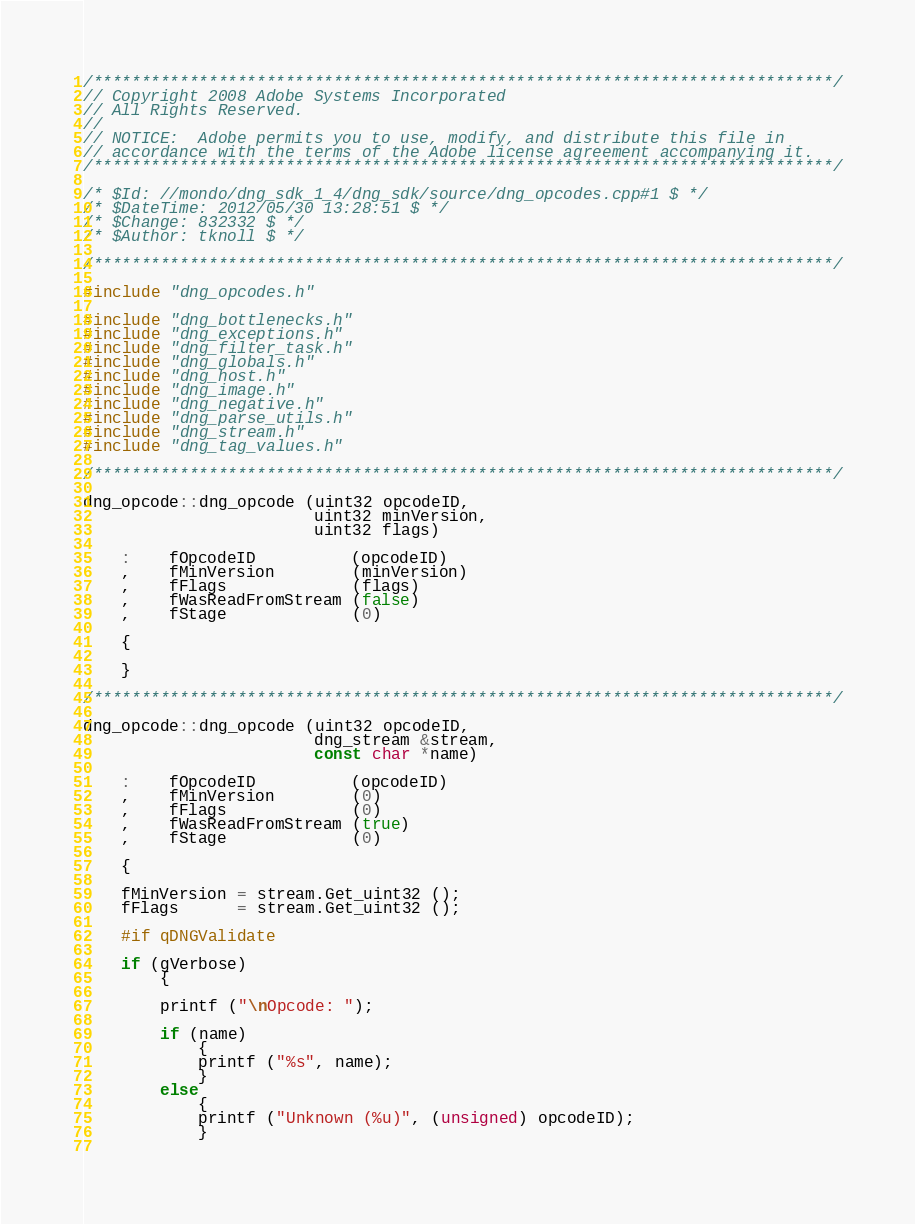<code> <loc_0><loc_0><loc_500><loc_500><_C++_>/*****************************************************************************/
// Copyright 2008 Adobe Systems Incorporated
// All Rights Reserved.
//
// NOTICE:  Adobe permits you to use, modify, and distribute this file in
// accordance with the terms of the Adobe license agreement accompanying it.
/*****************************************************************************/

/* $Id: //mondo/dng_sdk_1_4/dng_sdk/source/dng_opcodes.cpp#1 $ */ 
/* $DateTime: 2012/05/30 13:28:51 $ */
/* $Change: 832332 $ */
/* $Author: tknoll $ */

/*****************************************************************************/

#include "dng_opcodes.h"

#include "dng_bottlenecks.h"
#include "dng_exceptions.h"
#include "dng_filter_task.h"
#include "dng_globals.h"
#include "dng_host.h"
#include "dng_image.h"
#include "dng_negative.h"
#include "dng_parse_utils.h"
#include "dng_stream.h"
#include "dng_tag_values.h"

/*****************************************************************************/

dng_opcode::dng_opcode (uint32 opcodeID,
						uint32 minVersion,
						uint32 flags)
						
	:	fOpcodeID          (opcodeID)
	,	fMinVersion        (minVersion)
	,	fFlags             (flags)
	,	fWasReadFromStream (false)
	,	fStage             (0)
	
	{
	
	}
					
/*****************************************************************************/

dng_opcode::dng_opcode (uint32 opcodeID,
					    dng_stream &stream,
						const char *name)
						
	:	fOpcodeID          (opcodeID)
	,	fMinVersion        (0)
	,	fFlags             (0)
	,	fWasReadFromStream (true)
	,	fStage             (0)
	
	{
	
	fMinVersion = stream.Get_uint32 ();
	fFlags      = stream.Get_uint32 ();
	
	#if qDNGValidate
	
	if (gVerbose)
		{
		
		printf ("\nOpcode: ");
		
		if (name)
			{
			printf ("%s", name);
			}
		else
			{
			printf ("Unknown (%u)", (unsigned) opcodeID);
			}
		</code> 